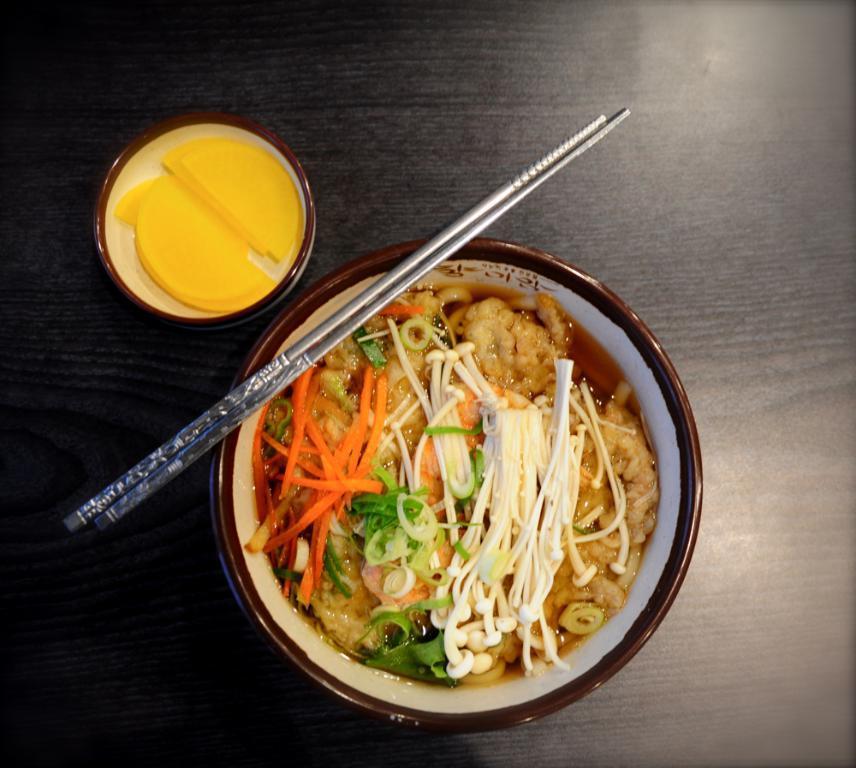In one or two sentences, can you explain what this image depicts? In this image, we can see a table, on the table, see a bowl with some food, on the bowl, we can also see two chopsticks. On the left side of the table, we can also see a bowl with some food. 